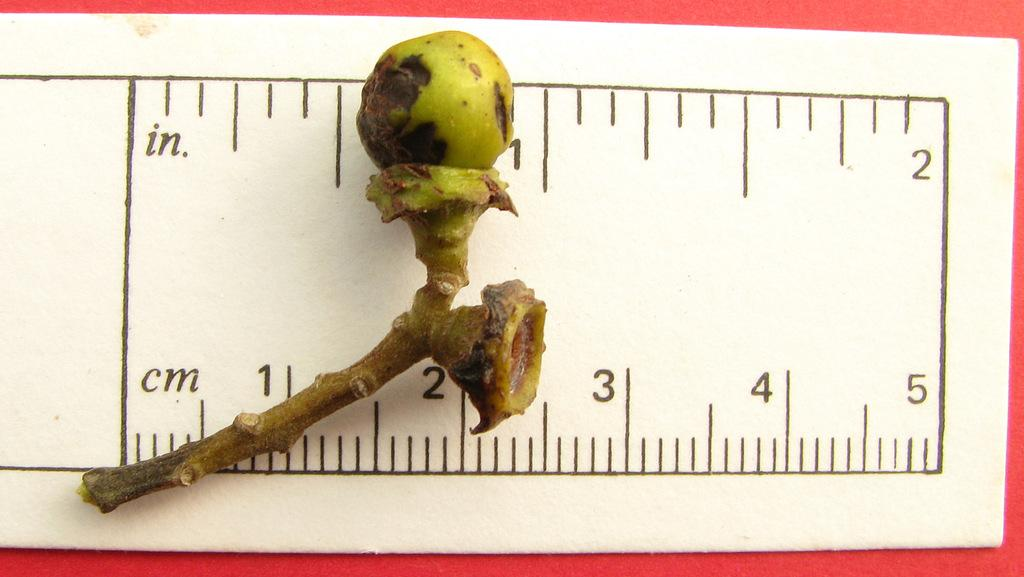<image>
Relay a brief, clear account of the picture shown. a ruler measuring a seed pod in CM or in. 